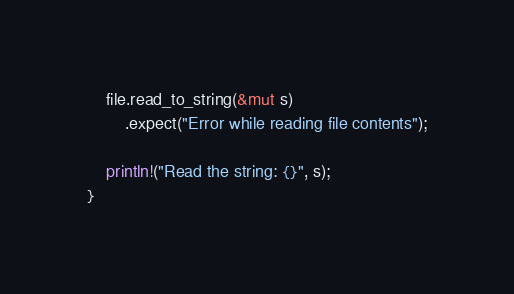<code> <loc_0><loc_0><loc_500><loc_500><_Rust_>    file.read_to_string(&mut s)
        .expect("Error while reading file contents");

    println!("Read the string: {}", s);
}
</code> 